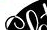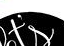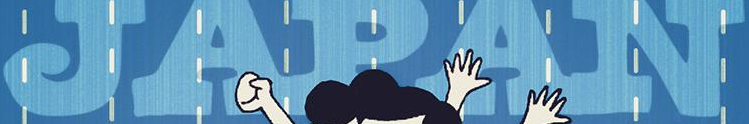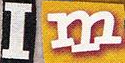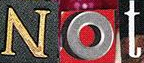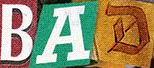Read the text from these images in sequence, separated by a semicolon. ##; t's; JAPAN; Im; Not; BAD 